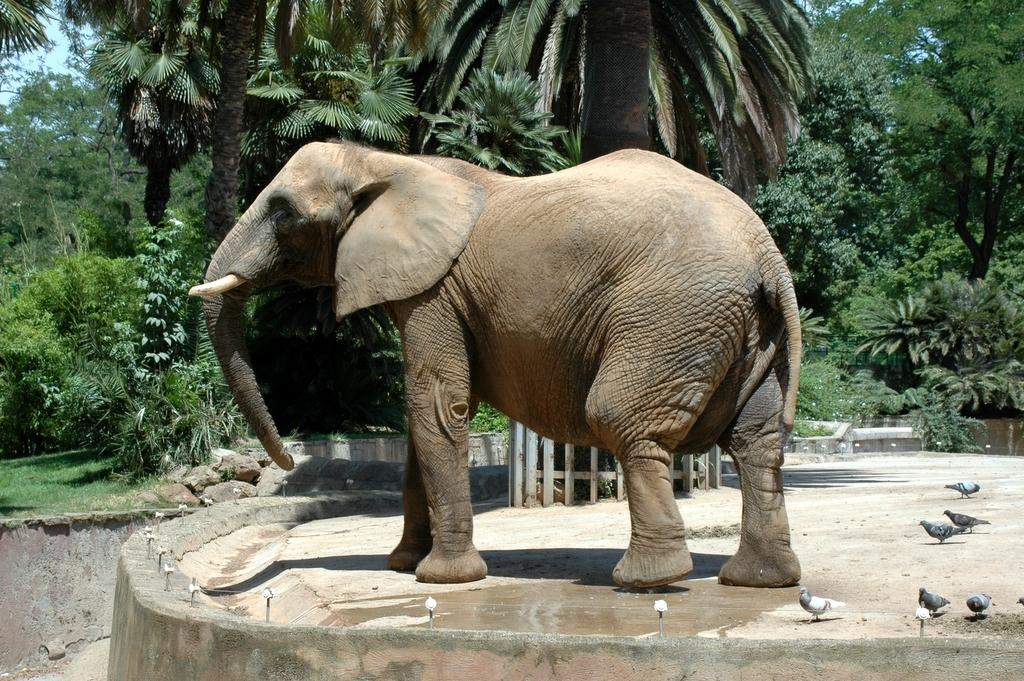What animal is the main subject of the image? There is an elephant in the image. Where is the elephant located? The elephant is standing on a concrete platform. What can be seen on the right side of the image? There are birds on the right side of the image. What is visible in the background of the image? There is a fence, grass, plants, trees, and the sky visible in the background of the image. What type of hat is the elephant wearing in the image? The elephant is not wearing a hat in the image. How does the elephant rest in the image? The image does not show the elephant resting; it is standing on a concrete platform. 